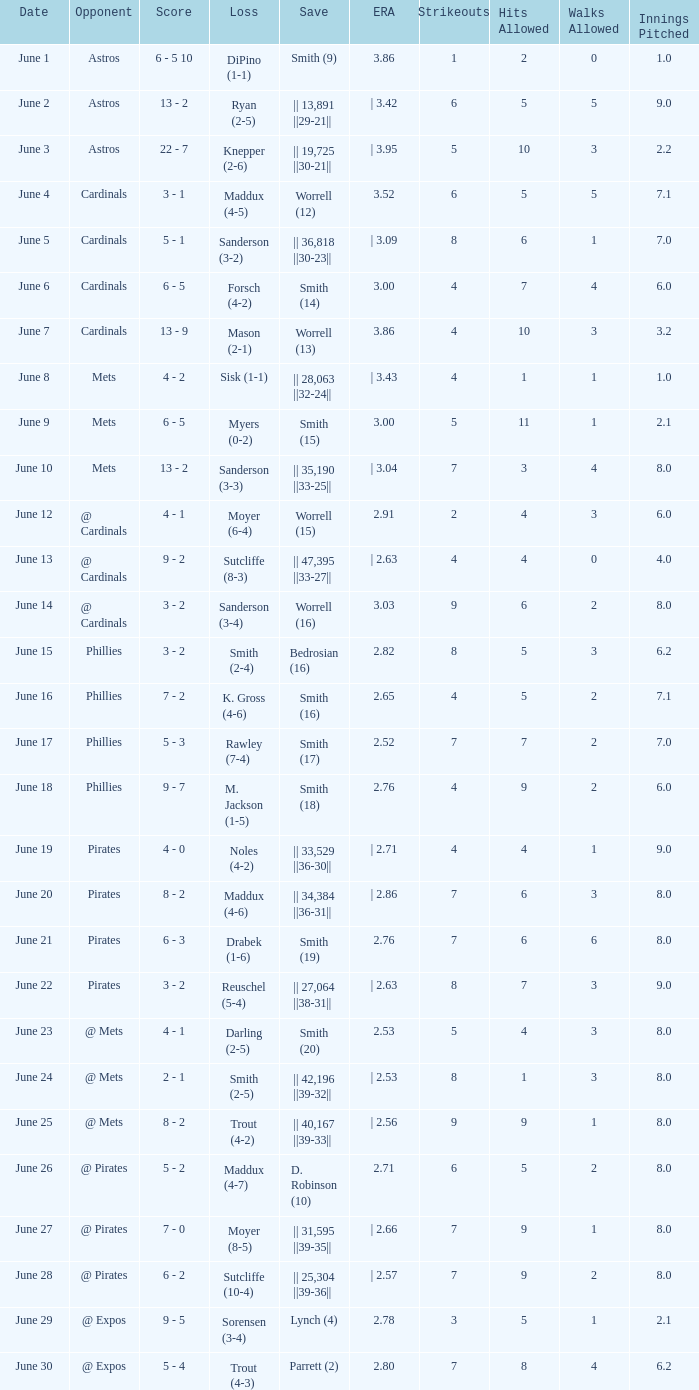What is the date for the game that included a loss of sutcliffe (10-4)? June 28. I'm looking to parse the entire table for insights. Could you assist me with that? {'header': ['Date', 'Opponent', 'Score', 'Loss', 'Save', 'ERA', 'Strikeouts', 'Hits Allowed', 'Walks Allowed', 'Innings Pitched'], 'rows': [['June 1', 'Astros', '6 - 5 10', 'DiPino (1-1)', 'Smith (9)', '3.86', '1', '2', '0', '1.0'], ['June 2', 'Astros', '13 - 2', 'Ryan (2-5)', '|| 13,891 ||29-21||', '| 3.42', '6', '5', '5', '9.0'], ['June 3', 'Astros', '22 - 7', 'Knepper (2-6)', '|| 19,725 ||30-21||', '| 3.95', '5', '10', '3', '2.2'], ['June 4', 'Cardinals', '3 - 1', 'Maddux (4-5)', 'Worrell (12)', '3.52', '6', '5', '5', '7.1'], ['June 5', 'Cardinals', '5 - 1', 'Sanderson (3-2)', '|| 36,818 ||30-23||', '| 3.09', '8', '6', '1', '7.0'], ['June 6', 'Cardinals', '6 - 5', 'Forsch (4-2)', 'Smith (14)', '3.00', '4', '7', '4', '6.0'], ['June 7', 'Cardinals', '13 - 9', 'Mason (2-1)', 'Worrell (13)', '3.86', '4', '10', '3', '3.2'], ['June 8', 'Mets', '4 - 2', 'Sisk (1-1)', '|| 28,063 ||32-24||', '| 3.43', '4', '1', '1', '1.0'], ['June 9', 'Mets', '6 - 5', 'Myers (0-2)', 'Smith (15)', '3.00', '5', '11', '1', '2.1'], ['June 10', 'Mets', '13 - 2', 'Sanderson (3-3)', '|| 35,190 ||33-25||', '| 3.04', '7', '3', '4', '8.0'], ['June 12', '@ Cardinals', '4 - 1', 'Moyer (6-4)', 'Worrell (15)', '2.91', '2', '4', '3', '6.0'], ['June 13', '@ Cardinals', '9 - 2', 'Sutcliffe (8-3)', '|| 47,395 ||33-27||', '| 2.63', '4', '4', '0', '4.0'], ['June 14', '@ Cardinals', '3 - 2', 'Sanderson (3-4)', 'Worrell (16)', '3.03', '9', '6', '2', '8.0'], ['June 15', 'Phillies', '3 - 2', 'Smith (2-4)', 'Bedrosian (16)', '2.82', '8', '5', '3', '6.2'], ['June 16', 'Phillies', '7 - 2', 'K. Gross (4-6)', 'Smith (16)', '2.65', '4', '5', '2', '7.1'], ['June 17', 'Phillies', '5 - 3', 'Rawley (7-4)', 'Smith (17)', '2.52', '7', '7', '2', '7.0'], ['June 18', 'Phillies', '9 - 7', 'M. Jackson (1-5)', 'Smith (18)', '2.76', '4', '9', '2', '6.0'], ['June 19', 'Pirates', '4 - 0', 'Noles (4-2)', '|| 33,529 ||36-30||', '| 2.71', '4', '4', '1', '9.0'], ['June 20', 'Pirates', '8 - 2', 'Maddux (4-6)', '|| 34,384 ||36-31||', '| 2.86', '7', '6', '3', '8.0'], ['June 21', 'Pirates', '6 - 3', 'Drabek (1-6)', 'Smith (19)', '2.76', '7', '6', '6', '8.0'], ['June 22', 'Pirates', '3 - 2', 'Reuschel (5-4)', '|| 27,064 ||38-31||', '| 2.63', '8', '7', '3', '9.0'], ['June 23', '@ Mets', '4 - 1', 'Darling (2-5)', 'Smith (20)', '2.53', '5', '4', '3', '8.0'], ['June 24', '@ Mets', '2 - 1', 'Smith (2-5)', '|| 42,196 ||39-32||', '| 2.53', '8', '1', '3', '8.0'], ['June 25', '@ Mets', '8 - 2', 'Trout (4-2)', '|| 40,167 ||39-33||', '| 2.56', '9', '9', '1', '8.0'], ['June 26', '@ Pirates', '5 - 2', 'Maddux (4-7)', 'D. Robinson (10)', '2.71', '6', '5', '2', '8.0'], ['June 27', '@ Pirates', '7 - 0', 'Moyer (8-5)', '|| 31,595 ||39-35||', '| 2.66', '7', '9', '1', '8.0'], ['June 28', '@ Pirates', '6 - 2', 'Sutcliffe (10-4)', '|| 25,304 ||39-36||', '| 2.57', '7', '9', '2', '8.0'], ['June 29', '@ Expos', '9 - 5', 'Sorensen (3-4)', 'Lynch (4)', '2.78', '3', '5', '1', '2.1'], ['June 30', '@ Expos', '5 - 4', 'Trout (4-3)', 'Parrett (2)', '2.80', '7', '8', '4', '6.2']]} 